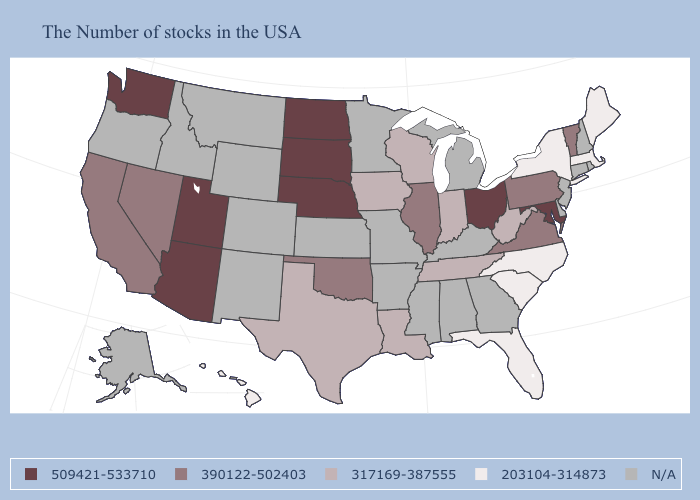What is the value of Idaho?
Keep it brief. N/A. What is the lowest value in the USA?
Give a very brief answer. 203104-314873. Among the states that border Wisconsin , which have the highest value?
Give a very brief answer. Illinois. What is the highest value in the West ?
Keep it brief. 509421-533710. What is the value of Kansas?
Be succinct. N/A. Name the states that have a value in the range 317169-387555?
Quick response, please. West Virginia, Indiana, Tennessee, Wisconsin, Louisiana, Iowa, Texas. Does the map have missing data?
Short answer required. Yes. What is the value of Louisiana?
Give a very brief answer. 317169-387555. What is the lowest value in states that border Kentucky?
Answer briefly. 317169-387555. Name the states that have a value in the range 317169-387555?
Give a very brief answer. West Virginia, Indiana, Tennessee, Wisconsin, Louisiana, Iowa, Texas. Name the states that have a value in the range 509421-533710?
Keep it brief. Maryland, Ohio, Nebraska, South Dakota, North Dakota, Utah, Arizona, Washington. Does the map have missing data?
Keep it brief. Yes. 